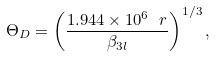Convert formula to latex. <formula><loc_0><loc_0><loc_500><loc_500>\Theta _ { D } = \left ( \frac { 1 . 9 4 4 \times 1 0 ^ { 6 } \ r } { \beta _ { 3 l } } \right ) ^ { 1 / 3 } ,</formula> 